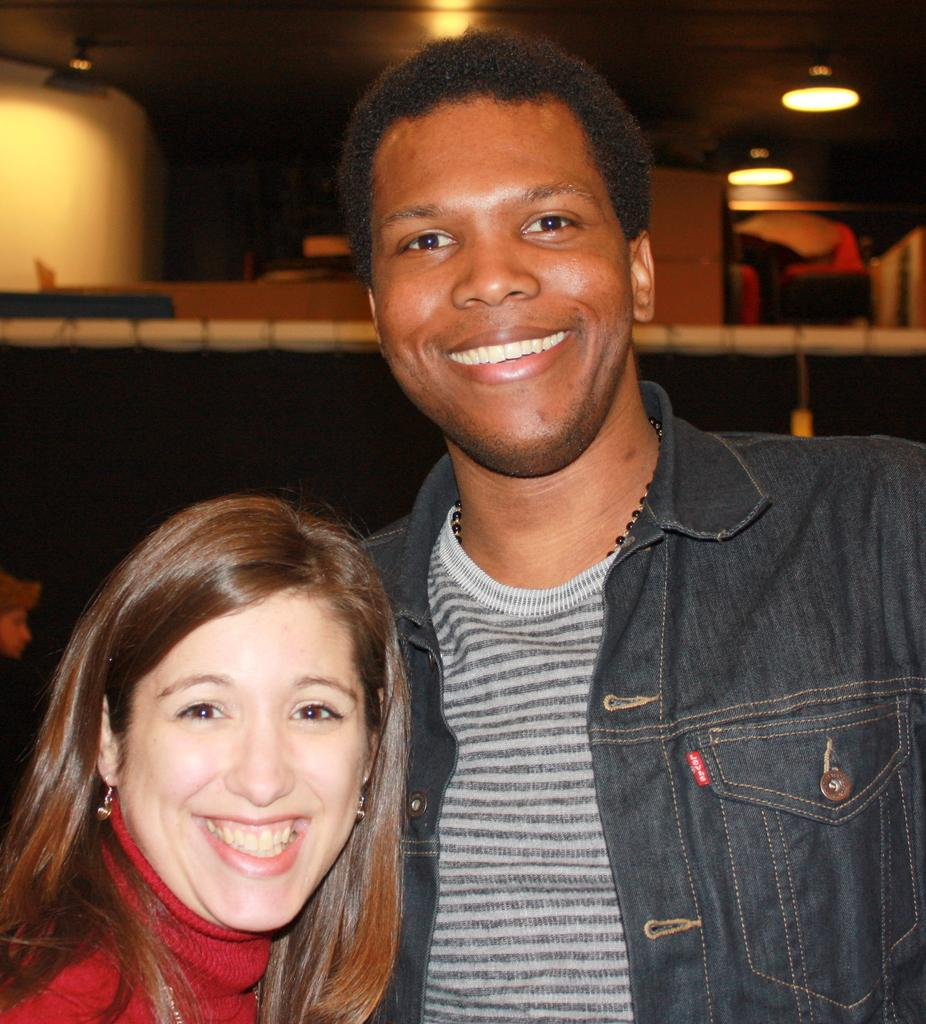Who is present in the image? There is a man and a woman in the image. What are the facial expressions of the people in the image? Both the man and the woman are smiling in the image. What can be seen in the background of the image? There are ceiling lights in the background of the image. What type of eggnog is being served in the image? There is no eggnog present in the image. What kind of insurance policy is being discussed in the image? There is no discussion of insurance in the image. 